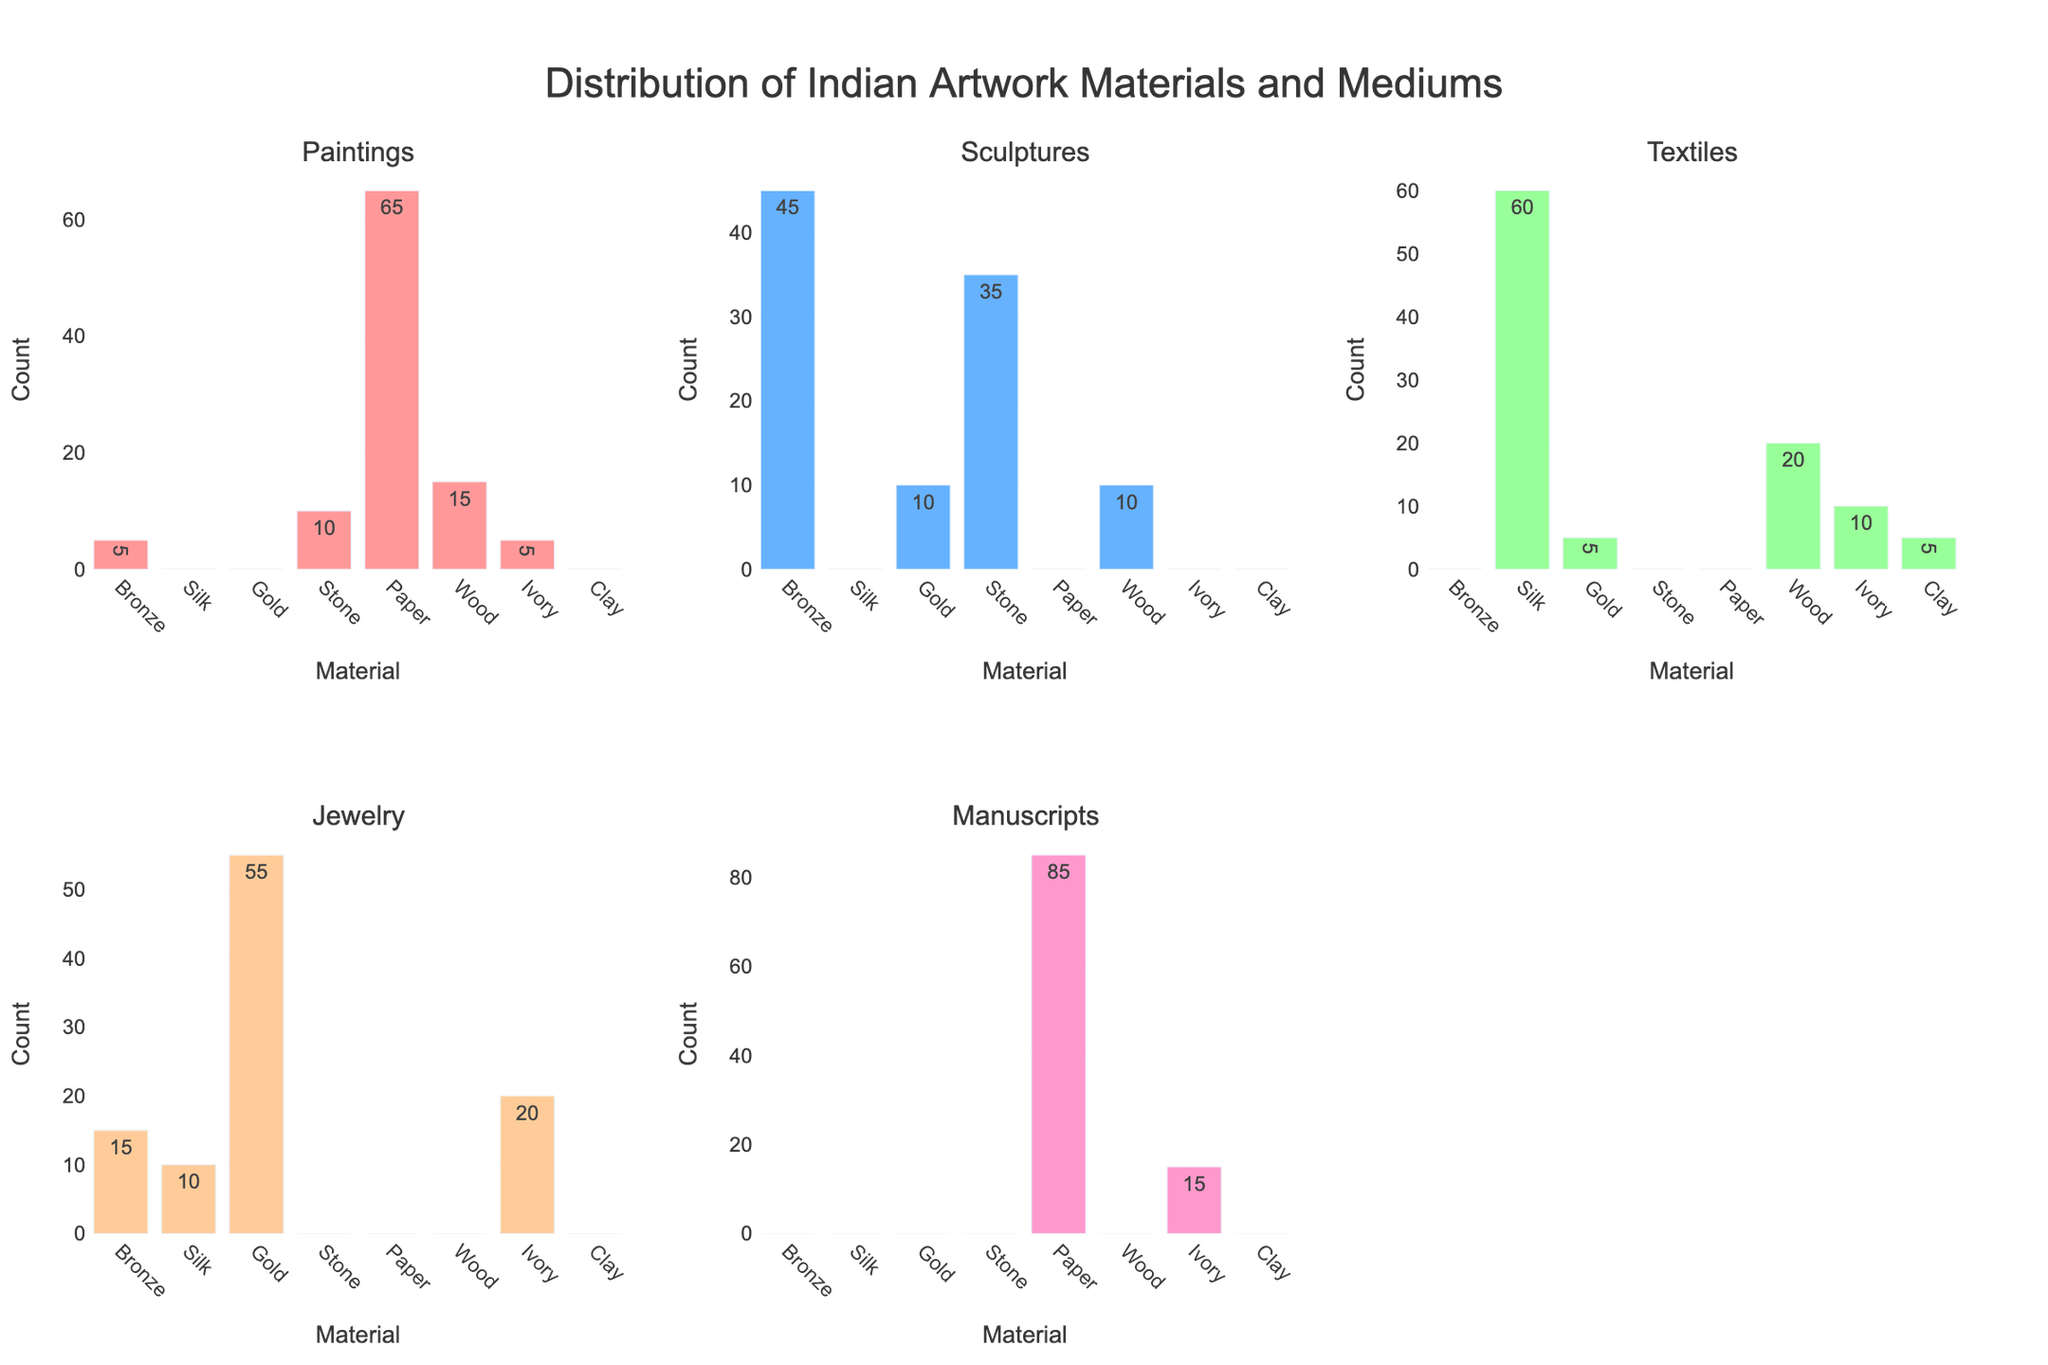What is the title of the figure? The title of the figure is usually displayed prominently at the top of the plot.
Answer: Distribution of Indian Artwork Materials and Mediums Which material has the highest count in Sculptures? To find this, look for the highest bar in the Sculptures subplot and identify the material associated with it.
Answer: Bronze How many paintings are made on paper? Locate the Paintings subplot and find the bar that corresponds to Paper, then read off the count.
Answer: 65 Which material is used exclusively for Jewelry? In the Jewelry subplot, identify the material bar with a count that has no other count in the remaining subplots.
Answer: Gold In which subplot does Wood have equal number of items as Bronze? Identify the counts for Wood and Bronze in all subplots and see where they are equal. They match in Paintings.
Answer: Paintings What is the total count of manuscripts made from Paper and Ivory? Sum the counts of manuscripts made from Paper (85) and Ivory (15).
Answer: 100 Compare the counts of Textiles made from Silk and Wood. Which is greater? Locate the Textiles subplot, compare the bar heights for Silk and Wood. Silk has 60 and Wood has 20.
Answer: Silk Which material is used in the highest number of different artwork mediums? Count the different artwork mediums in which each material appears based on non-zero bars in subplots.
Answer: Bronze What is the median count of items made from Silk across all categories? List the counts of Silk in each category (0, 0, 60, 10, 0), sort them (0, 0, 0, 10, 60), and find the median value.
Answer: 0 Is Wood used more in Paintings or Sculptures? By how much? Compare the counts of Wood in Paintings (15) and Sculptures (10). Calculate the difference.
Answer: Paintings, by 5 